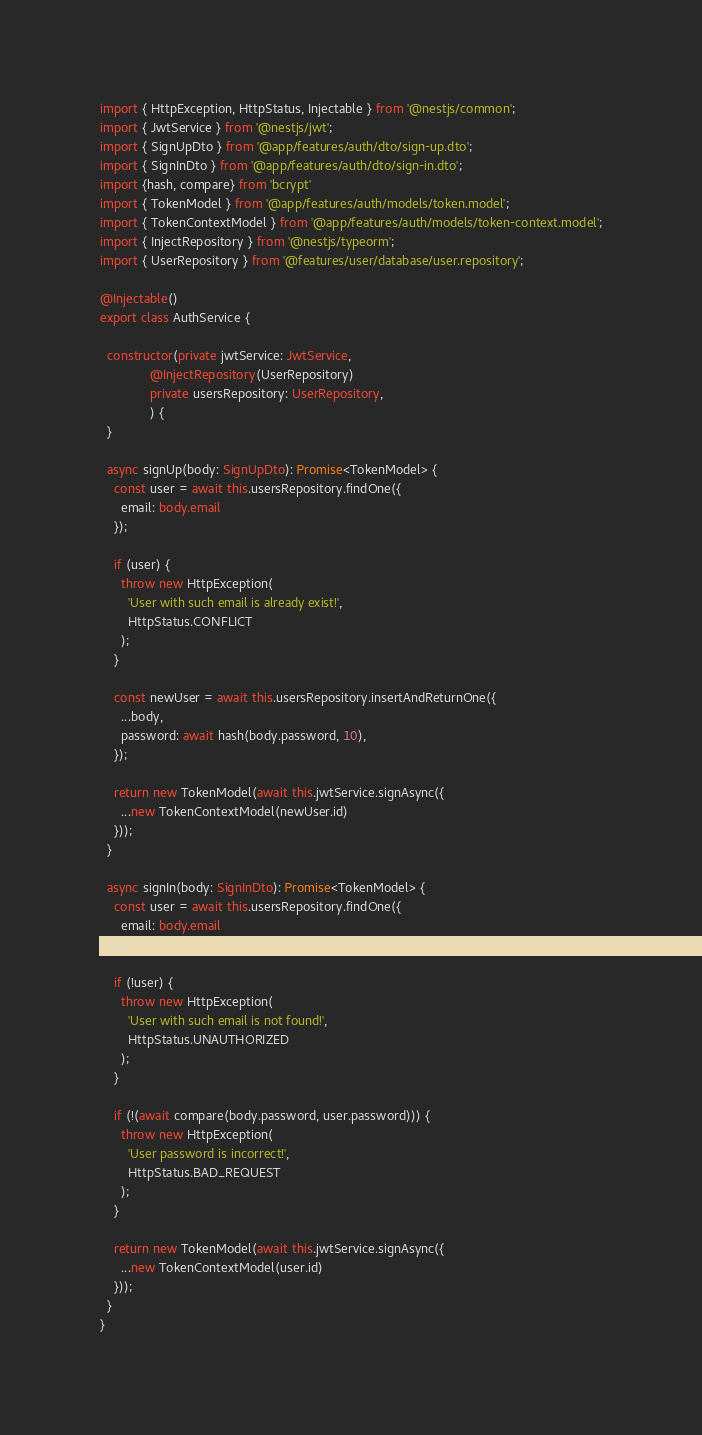<code> <loc_0><loc_0><loc_500><loc_500><_TypeScript_>import { HttpException, HttpStatus, Injectable } from '@nestjs/common';
import { JwtService } from '@nestjs/jwt';
import { SignUpDto } from '@app/features/auth/dto/sign-up.dto';
import { SignInDto } from '@app/features/auth/dto/sign-in.dto';
import {hash, compare} from 'bcrypt'
import { TokenModel } from '@app/features/auth/models/token.model';
import { TokenContextModel } from '@app/features/auth/models/token-context.model';
import { InjectRepository } from '@nestjs/typeorm';
import { UserRepository } from '@features/user/database/user.repository';

@Injectable()
export class AuthService {

  constructor(private jwtService: JwtService,
              @InjectRepository(UserRepository)
              private usersRepository: UserRepository,
              ) {
  }

  async signUp(body: SignUpDto): Promise<TokenModel> {
    const user = await this.usersRepository.findOne({
      email: body.email
    });

    if (user) {
      throw new HttpException(
        'User with such email is already exist!',
        HttpStatus.CONFLICT
      );
    }

    const newUser = await this.usersRepository.insertAndReturnOne({
      ...body,
      password: await hash(body.password, 10),
    });

    return new TokenModel(await this.jwtService.signAsync({
      ...new TokenContextModel(newUser.id)
    }));
  }

  async signIn(body: SignInDto): Promise<TokenModel> {
    const user = await this.usersRepository.findOne({
      email: body.email
    });

    if (!user) {
      throw new HttpException(
        'User with such email is not found!',
        HttpStatus.UNAUTHORIZED
      );
    }

    if (!(await compare(body.password, user.password))) {
      throw new HttpException(
        'User password is incorrect!',
        HttpStatus.BAD_REQUEST
      );
    }

    return new TokenModel(await this.jwtService.signAsync({
      ...new TokenContextModel(user.id)
    }));
  }
}
</code> 